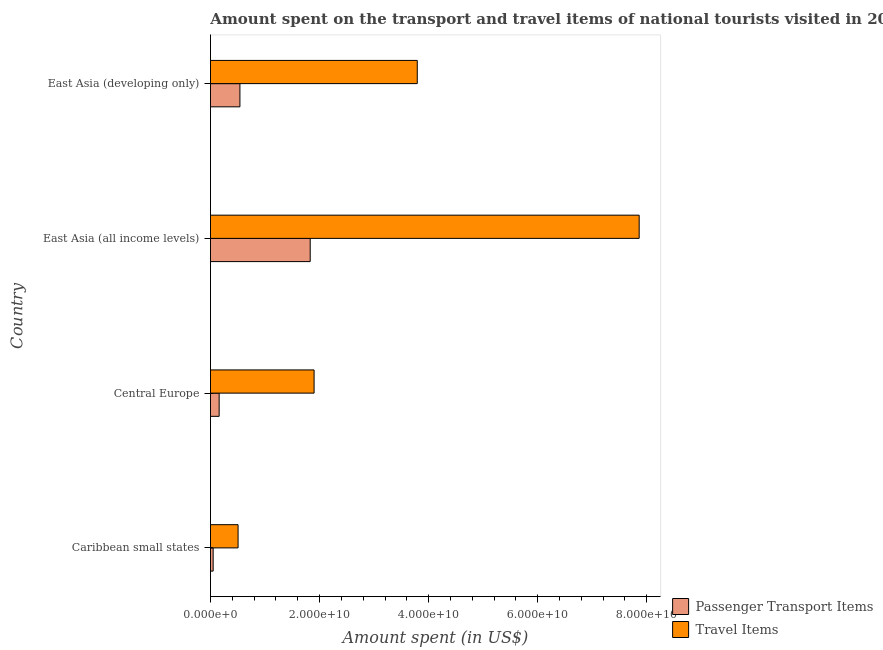How many different coloured bars are there?
Offer a very short reply. 2. How many groups of bars are there?
Keep it short and to the point. 4. Are the number of bars on each tick of the Y-axis equal?
Give a very brief answer. Yes. What is the label of the 1st group of bars from the top?
Keep it short and to the point. East Asia (developing only). In how many cases, is the number of bars for a given country not equal to the number of legend labels?
Offer a terse response. 0. What is the amount spent in travel items in Caribbean small states?
Your answer should be compact. 5.06e+09. Across all countries, what is the maximum amount spent on passenger transport items?
Offer a very short reply. 1.83e+1. Across all countries, what is the minimum amount spent in travel items?
Keep it short and to the point. 5.06e+09. In which country was the amount spent on passenger transport items maximum?
Your answer should be very brief. East Asia (all income levels). In which country was the amount spent on passenger transport items minimum?
Provide a short and direct response. Caribbean small states. What is the total amount spent in travel items in the graph?
Keep it short and to the point. 1.41e+11. What is the difference between the amount spent in travel items in Central Europe and that in East Asia (developing only)?
Provide a short and direct response. -1.89e+1. What is the difference between the amount spent in travel items in Caribbean small states and the amount spent on passenger transport items in East Asia (developing only)?
Give a very brief answer. -3.36e+08. What is the average amount spent in travel items per country?
Offer a very short reply. 3.51e+1. What is the difference between the amount spent in travel items and amount spent on passenger transport items in East Asia (developing only)?
Make the answer very short. 3.25e+1. What is the ratio of the amount spent in travel items in East Asia (all income levels) to that in East Asia (developing only)?
Offer a very short reply. 2.07. What is the difference between the highest and the second highest amount spent on passenger transport items?
Make the answer very short. 1.29e+1. What is the difference between the highest and the lowest amount spent on passenger transport items?
Ensure brevity in your answer.  1.78e+1. In how many countries, is the amount spent in travel items greater than the average amount spent in travel items taken over all countries?
Ensure brevity in your answer.  2. What does the 1st bar from the top in Central Europe represents?
Provide a succinct answer. Travel Items. What does the 1st bar from the bottom in East Asia (developing only) represents?
Your answer should be compact. Passenger Transport Items. How many bars are there?
Provide a short and direct response. 8. How many countries are there in the graph?
Ensure brevity in your answer.  4. What is the difference between two consecutive major ticks on the X-axis?
Provide a succinct answer. 2.00e+1. Does the graph contain any zero values?
Make the answer very short. No. How are the legend labels stacked?
Keep it short and to the point. Vertical. What is the title of the graph?
Give a very brief answer. Amount spent on the transport and travel items of national tourists visited in 2000. Does "Official aid received" appear as one of the legend labels in the graph?
Offer a terse response. No. What is the label or title of the X-axis?
Your response must be concise. Amount spent (in US$). What is the label or title of the Y-axis?
Your response must be concise. Country. What is the Amount spent (in US$) of Passenger Transport Items in Caribbean small states?
Offer a terse response. 4.92e+08. What is the Amount spent (in US$) in Travel Items in Caribbean small states?
Provide a short and direct response. 5.06e+09. What is the Amount spent (in US$) of Passenger Transport Items in Central Europe?
Your answer should be compact. 1.59e+09. What is the Amount spent (in US$) in Travel Items in Central Europe?
Your answer should be compact. 1.90e+1. What is the Amount spent (in US$) of Passenger Transport Items in East Asia (all income levels)?
Offer a terse response. 1.83e+1. What is the Amount spent (in US$) of Travel Items in East Asia (all income levels)?
Provide a short and direct response. 7.86e+1. What is the Amount spent (in US$) in Passenger Transport Items in East Asia (developing only)?
Ensure brevity in your answer.  5.40e+09. What is the Amount spent (in US$) of Travel Items in East Asia (developing only)?
Provide a short and direct response. 3.79e+1. Across all countries, what is the maximum Amount spent (in US$) in Passenger Transport Items?
Your answer should be very brief. 1.83e+1. Across all countries, what is the maximum Amount spent (in US$) in Travel Items?
Provide a succinct answer. 7.86e+1. Across all countries, what is the minimum Amount spent (in US$) of Passenger Transport Items?
Keep it short and to the point. 4.92e+08. Across all countries, what is the minimum Amount spent (in US$) of Travel Items?
Your answer should be compact. 5.06e+09. What is the total Amount spent (in US$) of Passenger Transport Items in the graph?
Provide a short and direct response. 2.58e+1. What is the total Amount spent (in US$) in Travel Items in the graph?
Your response must be concise. 1.41e+11. What is the difference between the Amount spent (in US$) of Passenger Transport Items in Caribbean small states and that in Central Europe?
Ensure brevity in your answer.  -1.10e+09. What is the difference between the Amount spent (in US$) in Travel Items in Caribbean small states and that in Central Europe?
Provide a succinct answer. -1.39e+1. What is the difference between the Amount spent (in US$) in Passenger Transport Items in Caribbean small states and that in East Asia (all income levels)?
Your response must be concise. -1.78e+1. What is the difference between the Amount spent (in US$) in Travel Items in Caribbean small states and that in East Asia (all income levels)?
Ensure brevity in your answer.  -7.35e+1. What is the difference between the Amount spent (in US$) in Passenger Transport Items in Caribbean small states and that in East Asia (developing only)?
Make the answer very short. -4.91e+09. What is the difference between the Amount spent (in US$) of Travel Items in Caribbean small states and that in East Asia (developing only)?
Offer a very short reply. -3.29e+1. What is the difference between the Amount spent (in US$) in Passenger Transport Items in Central Europe and that in East Asia (all income levels)?
Provide a short and direct response. -1.67e+1. What is the difference between the Amount spent (in US$) in Travel Items in Central Europe and that in East Asia (all income levels)?
Keep it short and to the point. -5.96e+1. What is the difference between the Amount spent (in US$) of Passenger Transport Items in Central Europe and that in East Asia (developing only)?
Give a very brief answer. -3.81e+09. What is the difference between the Amount spent (in US$) of Travel Items in Central Europe and that in East Asia (developing only)?
Your answer should be compact. -1.89e+1. What is the difference between the Amount spent (in US$) in Passenger Transport Items in East Asia (all income levels) and that in East Asia (developing only)?
Your answer should be very brief. 1.29e+1. What is the difference between the Amount spent (in US$) in Travel Items in East Asia (all income levels) and that in East Asia (developing only)?
Provide a succinct answer. 4.07e+1. What is the difference between the Amount spent (in US$) of Passenger Transport Items in Caribbean small states and the Amount spent (in US$) of Travel Items in Central Europe?
Provide a short and direct response. -1.85e+1. What is the difference between the Amount spent (in US$) of Passenger Transport Items in Caribbean small states and the Amount spent (in US$) of Travel Items in East Asia (all income levels)?
Offer a terse response. -7.81e+1. What is the difference between the Amount spent (in US$) in Passenger Transport Items in Caribbean small states and the Amount spent (in US$) in Travel Items in East Asia (developing only)?
Provide a short and direct response. -3.74e+1. What is the difference between the Amount spent (in US$) of Passenger Transport Items in Central Europe and the Amount spent (in US$) of Travel Items in East Asia (all income levels)?
Ensure brevity in your answer.  -7.70e+1. What is the difference between the Amount spent (in US$) in Passenger Transport Items in Central Europe and the Amount spent (in US$) in Travel Items in East Asia (developing only)?
Keep it short and to the point. -3.63e+1. What is the difference between the Amount spent (in US$) of Passenger Transport Items in East Asia (all income levels) and the Amount spent (in US$) of Travel Items in East Asia (developing only)?
Make the answer very short. -1.96e+1. What is the average Amount spent (in US$) in Passenger Transport Items per country?
Ensure brevity in your answer.  6.44e+09. What is the average Amount spent (in US$) in Travel Items per country?
Provide a short and direct response. 3.51e+1. What is the difference between the Amount spent (in US$) in Passenger Transport Items and Amount spent (in US$) in Travel Items in Caribbean small states?
Your response must be concise. -4.57e+09. What is the difference between the Amount spent (in US$) in Passenger Transport Items and Amount spent (in US$) in Travel Items in Central Europe?
Provide a short and direct response. -1.74e+1. What is the difference between the Amount spent (in US$) of Passenger Transport Items and Amount spent (in US$) of Travel Items in East Asia (all income levels)?
Your answer should be very brief. -6.03e+1. What is the difference between the Amount spent (in US$) in Passenger Transport Items and Amount spent (in US$) in Travel Items in East Asia (developing only)?
Provide a short and direct response. -3.25e+1. What is the ratio of the Amount spent (in US$) in Passenger Transport Items in Caribbean small states to that in Central Europe?
Your answer should be very brief. 0.31. What is the ratio of the Amount spent (in US$) in Travel Items in Caribbean small states to that in Central Europe?
Keep it short and to the point. 0.27. What is the ratio of the Amount spent (in US$) in Passenger Transport Items in Caribbean small states to that in East Asia (all income levels)?
Offer a terse response. 0.03. What is the ratio of the Amount spent (in US$) of Travel Items in Caribbean small states to that in East Asia (all income levels)?
Your response must be concise. 0.06. What is the ratio of the Amount spent (in US$) of Passenger Transport Items in Caribbean small states to that in East Asia (developing only)?
Your response must be concise. 0.09. What is the ratio of the Amount spent (in US$) in Travel Items in Caribbean small states to that in East Asia (developing only)?
Give a very brief answer. 0.13. What is the ratio of the Amount spent (in US$) in Passenger Transport Items in Central Europe to that in East Asia (all income levels)?
Offer a very short reply. 0.09. What is the ratio of the Amount spent (in US$) of Travel Items in Central Europe to that in East Asia (all income levels)?
Ensure brevity in your answer.  0.24. What is the ratio of the Amount spent (in US$) in Passenger Transport Items in Central Europe to that in East Asia (developing only)?
Provide a succinct answer. 0.29. What is the ratio of the Amount spent (in US$) of Travel Items in Central Europe to that in East Asia (developing only)?
Give a very brief answer. 0.5. What is the ratio of the Amount spent (in US$) of Passenger Transport Items in East Asia (all income levels) to that in East Asia (developing only)?
Offer a very short reply. 3.39. What is the ratio of the Amount spent (in US$) in Travel Items in East Asia (all income levels) to that in East Asia (developing only)?
Make the answer very short. 2.07. What is the difference between the highest and the second highest Amount spent (in US$) in Passenger Transport Items?
Keep it short and to the point. 1.29e+1. What is the difference between the highest and the second highest Amount spent (in US$) in Travel Items?
Provide a succinct answer. 4.07e+1. What is the difference between the highest and the lowest Amount spent (in US$) of Passenger Transport Items?
Give a very brief answer. 1.78e+1. What is the difference between the highest and the lowest Amount spent (in US$) of Travel Items?
Make the answer very short. 7.35e+1. 